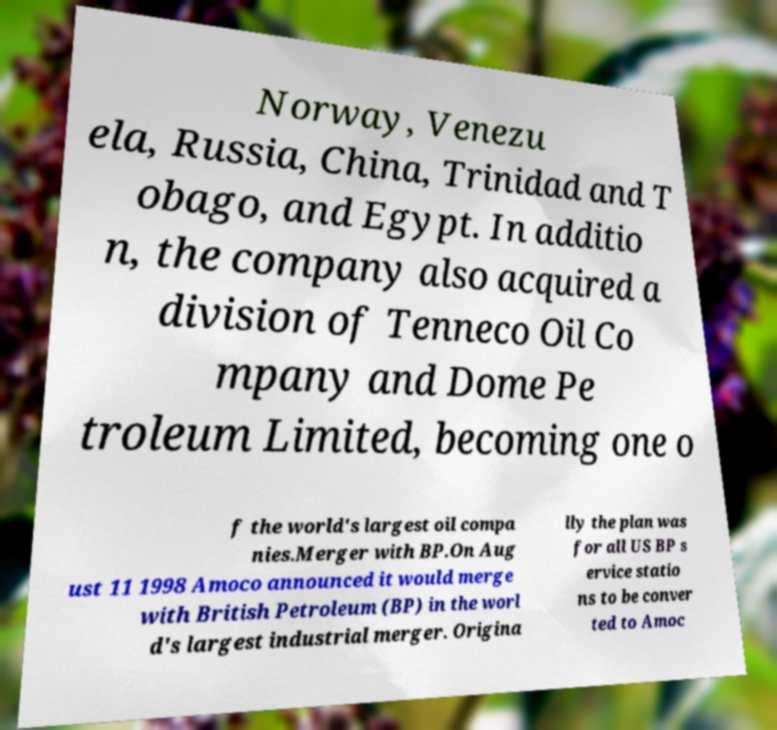Could you extract and type out the text from this image? Norway, Venezu ela, Russia, China, Trinidad and T obago, and Egypt. In additio n, the company also acquired a division of Tenneco Oil Co mpany and Dome Pe troleum Limited, becoming one o f the world's largest oil compa nies.Merger with BP.On Aug ust 11 1998 Amoco announced it would merge with British Petroleum (BP) in the worl d's largest industrial merger. Origina lly the plan was for all US BP s ervice statio ns to be conver ted to Amoc 